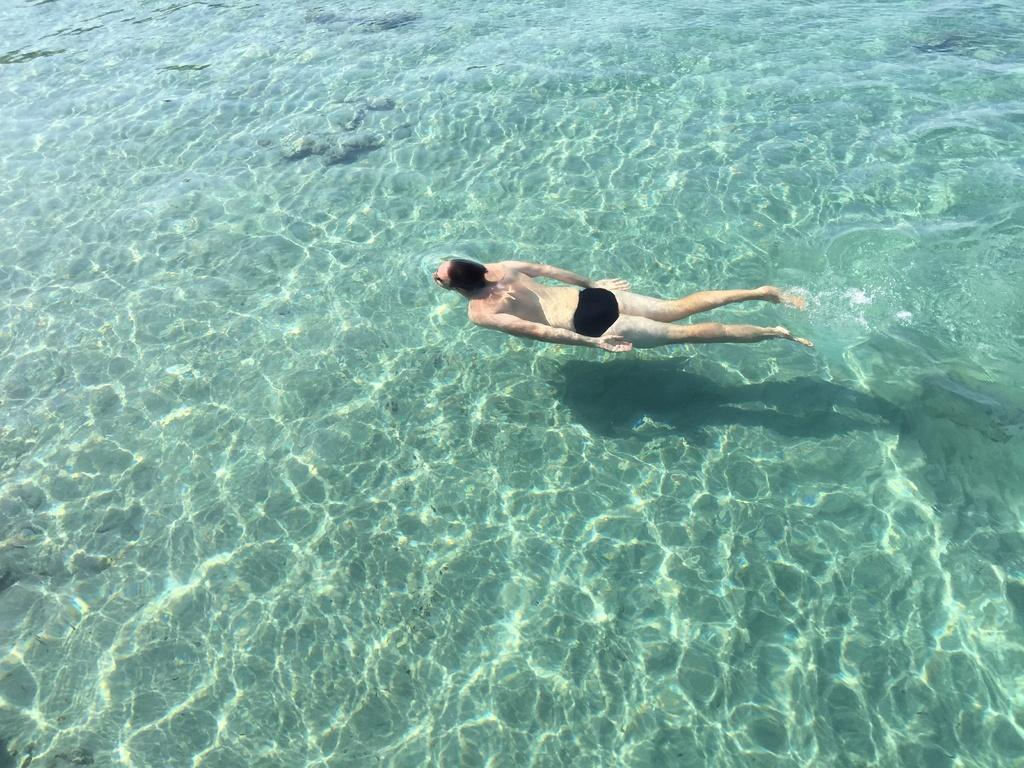What is the person in the image doing? There is a person swimming in the water. What else can be seen in the water besides the person? There are rocks in the water. What type of plant is growing on the person's underwear in the image? There is no plant or underwear present in the image; it only features a person swimming in the water and rocks. 